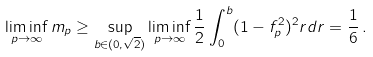Convert formula to latex. <formula><loc_0><loc_0><loc_500><loc_500>\liminf _ { p \to \infty } m _ { p } \geq \sup _ { b \in ( 0 , \sqrt { 2 } ) } \liminf _ { p \to \infty } \frac { 1 } { 2 } \int _ { 0 } ^ { b } ( 1 - f _ { p } ^ { 2 } ) ^ { 2 } r d r = \frac { 1 } { 6 } \, .</formula> 